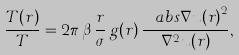<formula> <loc_0><loc_0><loc_500><loc_500>\frac { T ( r ) } { T } = 2 \pi \, \beta \, \frac { r } { \sigma } \, g ( r ) \, \frac { \ a b s { \nabla u ( r ) } ^ { 2 } } { \nabla ^ { 2 } u ( r ) } ,</formula> 